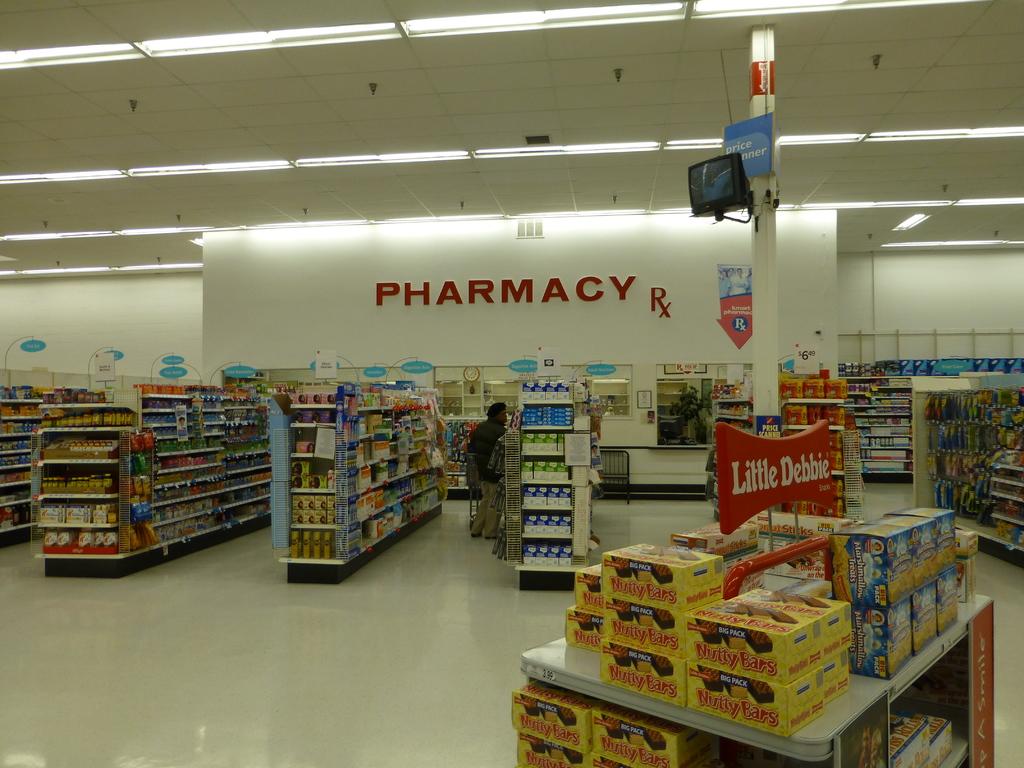Are the little debbies on sale?
Provide a short and direct response. Unanswerable. 